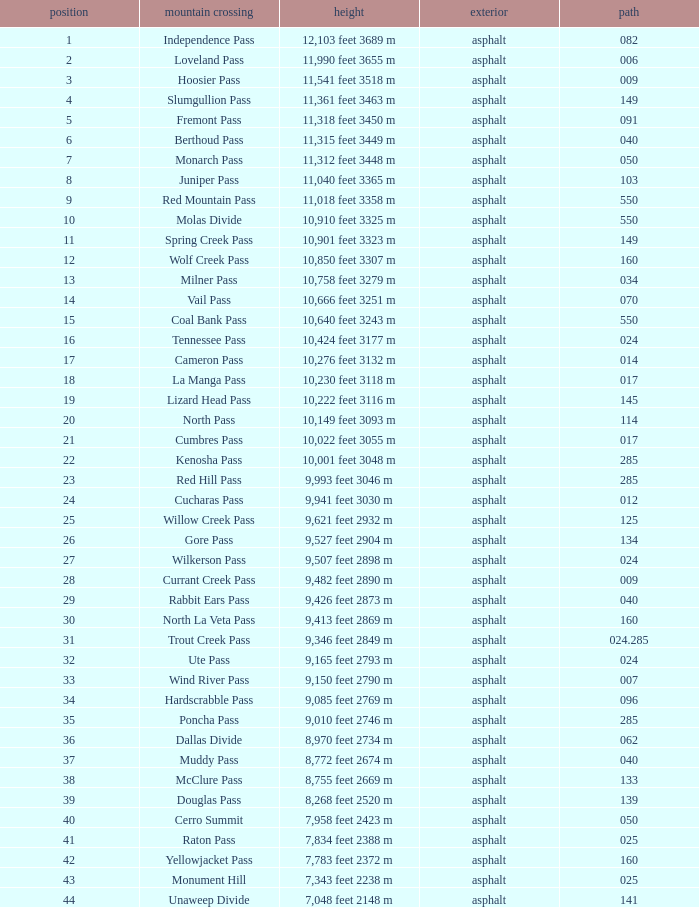What is the Mountain Pass with a 21 Rank? Cumbres Pass. 